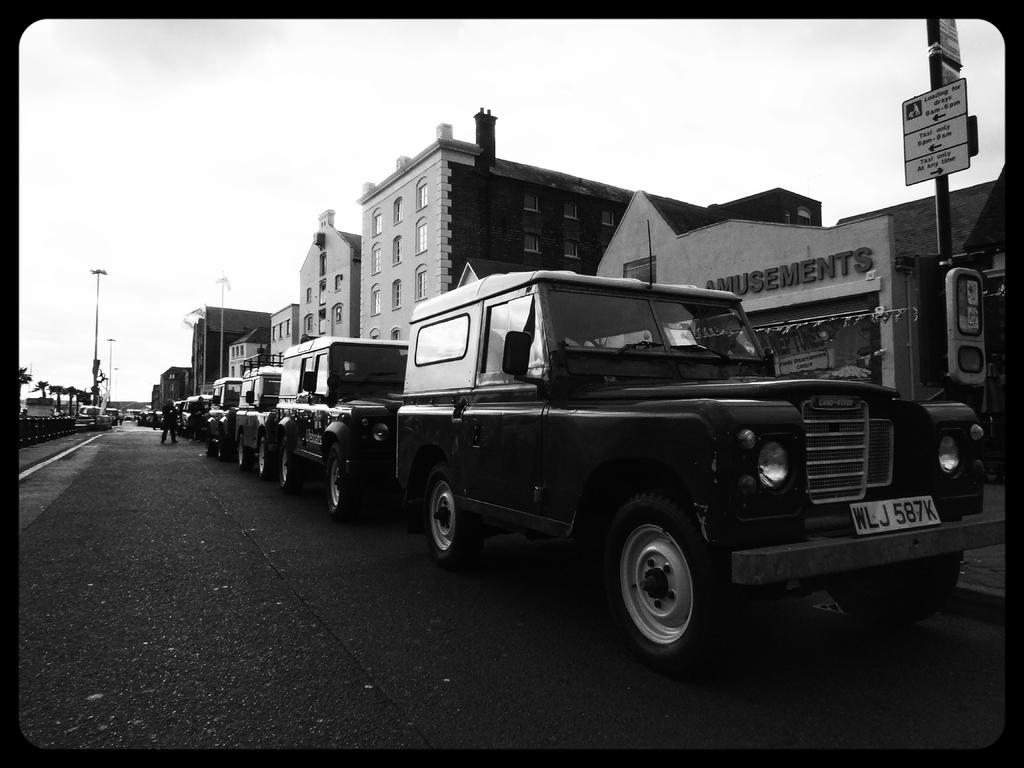In one or two sentences, can you explain what this image depicts? This is a black and white image. On the left side there is a road. There are many vehicles parked. Near to that there are many buildings with windows and names. On the right side there is a pole with boards. In the back there are many poles and sky. 